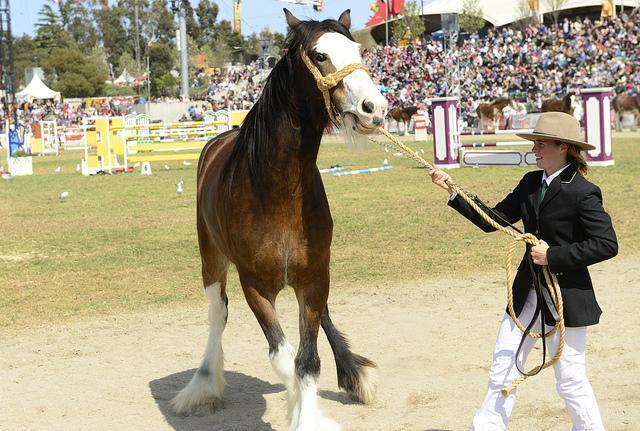What is it called when this animal moves?
Choose the correct response and explain in the format: 'Answer: answer
Rationale: rationale.'
Options: Trot, slither, slime, roll. Answer: trot.
Rationale: When a horse runs, they trot. 